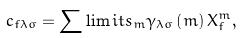Convert formula to latex. <formula><loc_0><loc_0><loc_500><loc_500>c _ { f \lambda \sigma } = \sum \lim i t s _ { m } \gamma _ { \lambda \sigma } \left ( m \right ) X _ { f } ^ { m } ,</formula> 